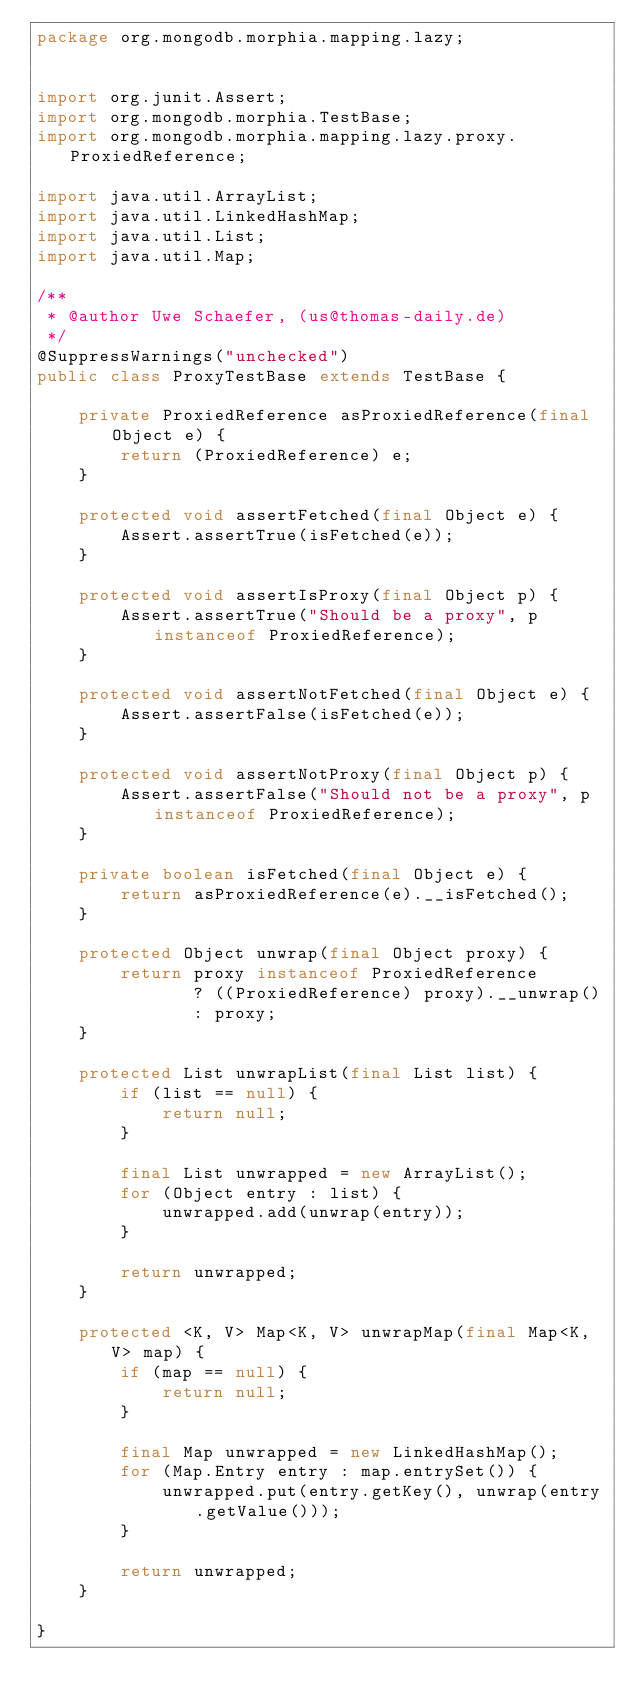<code> <loc_0><loc_0><loc_500><loc_500><_Java_>package org.mongodb.morphia.mapping.lazy;


import org.junit.Assert;
import org.mongodb.morphia.TestBase;
import org.mongodb.morphia.mapping.lazy.proxy.ProxiedReference;

import java.util.ArrayList;
import java.util.LinkedHashMap;
import java.util.List;
import java.util.Map;

/**
 * @author Uwe Schaefer, (us@thomas-daily.de)
 */
@SuppressWarnings("unchecked")
public class ProxyTestBase extends TestBase {

    private ProxiedReference asProxiedReference(final Object e) {
        return (ProxiedReference) e;
    }

    protected void assertFetched(final Object e) {
        Assert.assertTrue(isFetched(e));
    }

    protected void assertIsProxy(final Object p) {
        Assert.assertTrue("Should be a proxy", p instanceof ProxiedReference);
    }

    protected void assertNotFetched(final Object e) {
        Assert.assertFalse(isFetched(e));
    }

    protected void assertNotProxy(final Object p) {
        Assert.assertFalse("Should not be a proxy", p instanceof ProxiedReference);
    }

    private boolean isFetched(final Object e) {
        return asProxiedReference(e).__isFetched();
    }

    protected Object unwrap(final Object proxy) {
        return proxy instanceof ProxiedReference
               ? ((ProxiedReference) proxy).__unwrap()
               : proxy;
    }

    protected List unwrapList(final List list) {
        if (list == null) {
            return null;
        }

        final List unwrapped = new ArrayList();
        for (Object entry : list) {
            unwrapped.add(unwrap(entry));
        }

        return unwrapped;
    }

    protected <K, V> Map<K, V> unwrapMap(final Map<K, V> map) {
        if (map == null) {
            return null;
        }

        final Map unwrapped = new LinkedHashMap();
        for (Map.Entry entry : map.entrySet()) {
            unwrapped.put(entry.getKey(), unwrap(entry.getValue()));
        }

        return unwrapped;
    }

}
</code> 